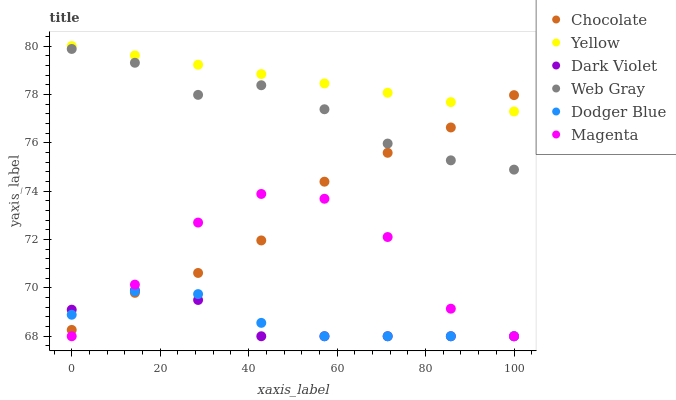Does Dark Violet have the minimum area under the curve?
Answer yes or no. Yes. Does Yellow have the maximum area under the curve?
Answer yes or no. Yes. Does Chocolate have the minimum area under the curve?
Answer yes or no. No. Does Chocolate have the maximum area under the curve?
Answer yes or no. No. Is Yellow the smoothest?
Answer yes or no. Yes. Is Magenta the roughest?
Answer yes or no. Yes. Is Dark Violet the smoothest?
Answer yes or no. No. Is Dark Violet the roughest?
Answer yes or no. No. Does Dark Violet have the lowest value?
Answer yes or no. Yes. Does Chocolate have the lowest value?
Answer yes or no. No. Does Yellow have the highest value?
Answer yes or no. Yes. Does Dark Violet have the highest value?
Answer yes or no. No. Is Dodger Blue less than Web Gray?
Answer yes or no. Yes. Is Yellow greater than Dodger Blue?
Answer yes or no. Yes. Does Dodger Blue intersect Chocolate?
Answer yes or no. Yes. Is Dodger Blue less than Chocolate?
Answer yes or no. No. Is Dodger Blue greater than Chocolate?
Answer yes or no. No. Does Dodger Blue intersect Web Gray?
Answer yes or no. No. 